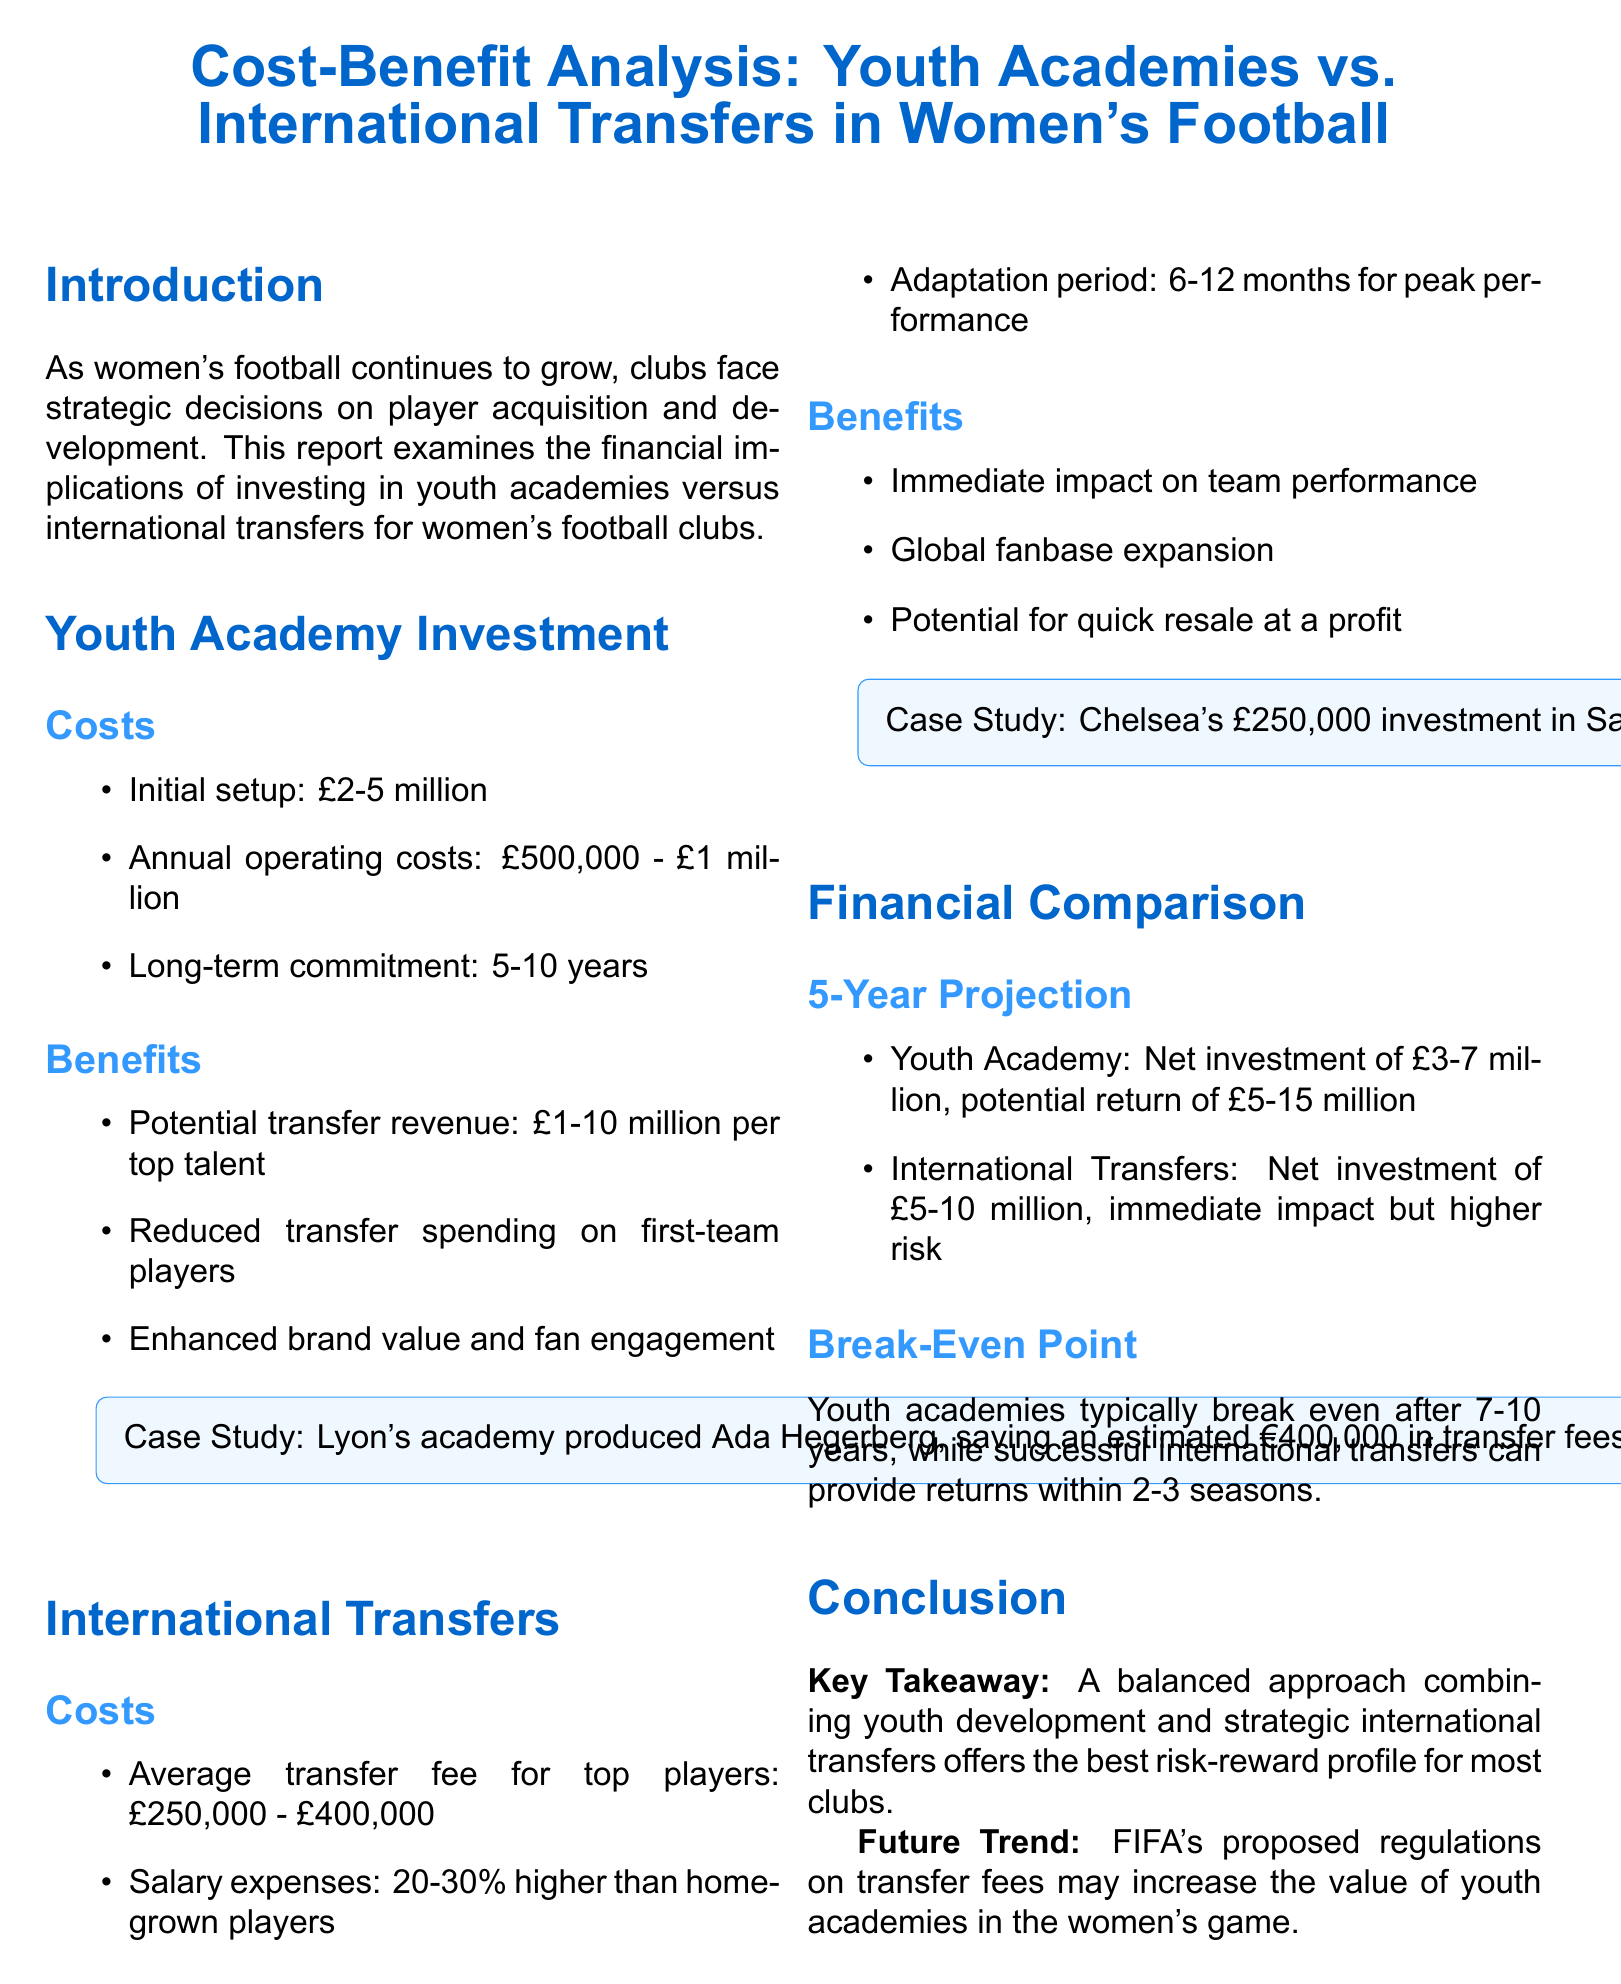What is the initial setup cost for youth academies? The report states that initial setup costs range from £2-5 million for youth academies.
Answer: £2-5 million What is the potential transfer revenue per top talent from youth academies? The document indicates that potential transfer revenue from youth academies can be between £1-10 million per top talent.
Answer: £1-10 million What is the average transfer fee for top players in international transfers? According to the document, the average transfer fee for top players is between £250,000 - £400,000.
Answer: £250,000 - £400,000 What is the estimated impact period for international transfers to see peak performance? The report mentions that there is an adaptation period of 6-12 months for international transfers to achieve peak performance.
Answer: 6-12 months What is the break-even point for youth academies? The document states that youth academies typically break even after 7-10 years.
Answer: 7-10 years Which club's youth academy produced Ada Hegerberg? The report references Lyon's youth academy, which produced Ada Hegerberg.
Answer: Lyon What is the estimated revenue generated from Chelsea's investment in Sam Kerr? The document states that Chelsea's investment in Sam Kerr led to increased ticket sales and merchandise revenue estimated at £1.5 million.
Answer: £1.5 million What is the net investment range for a youth academy over five years? The report suggests a net investment of £3-7 million for youth academies over a five-year projection.
Answer: £3-7 million What is the key takeaway regarding investment strategies for clubs? The document concludes that a balanced approach combining youth development and strategic international transfers offers the best risk-reward profile.
Answer: A balanced approach combining youth development and strategic international transfers 